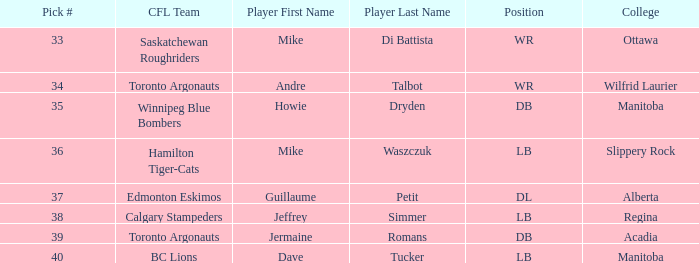What Player has a College that is alberta? Guillaume Petit. 